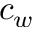<formula> <loc_0><loc_0><loc_500><loc_500>c _ { w }</formula> 